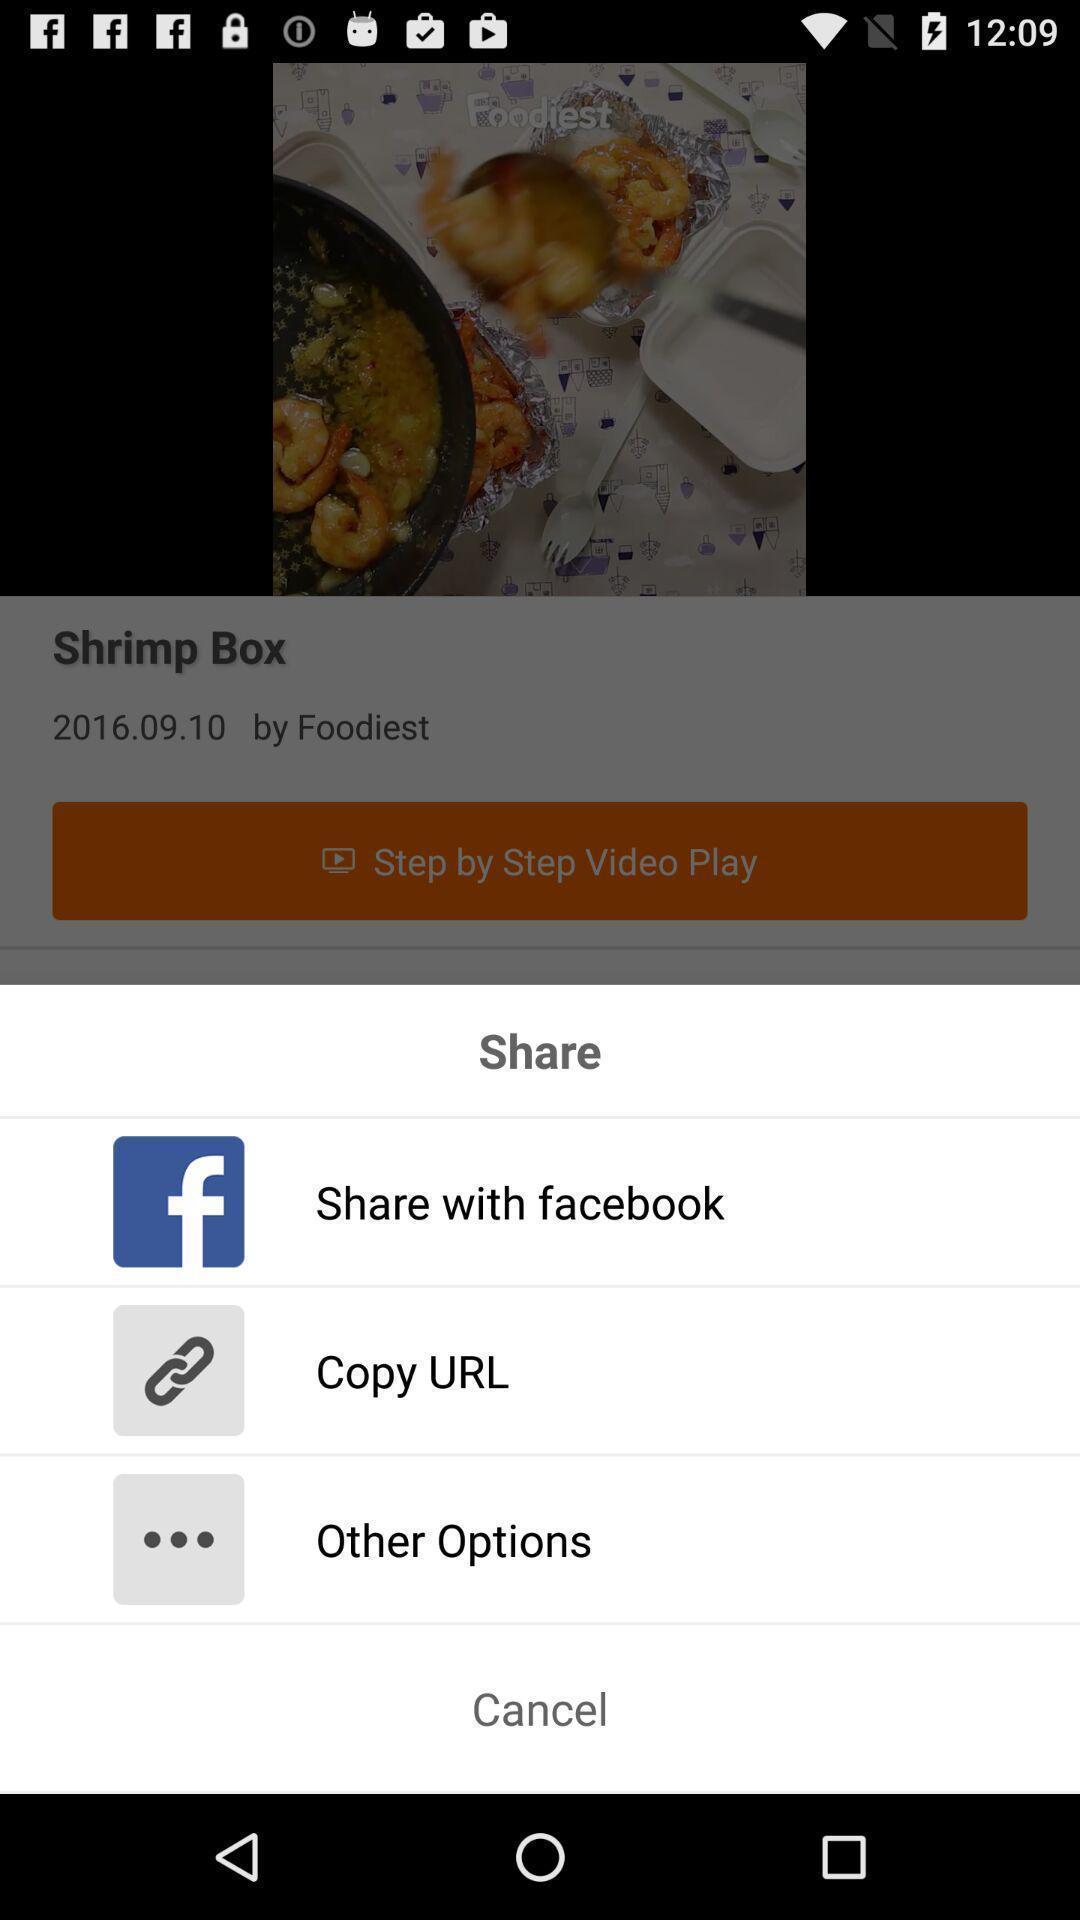Provide a textual representation of this image. Pop-up showing different sharing options. 